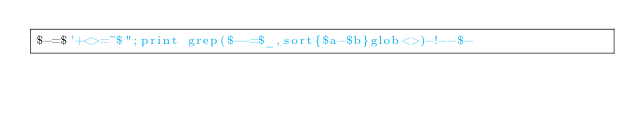Convert code to text. <code><loc_0><loc_0><loc_500><loc_500><_Perl_>$-=$'+<>=~$";print grep($--=$_,sort{$a-$b}glob<>)-!--$-</code> 